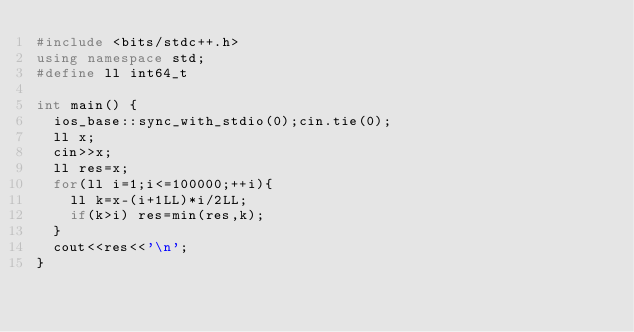Convert code to text. <code><loc_0><loc_0><loc_500><loc_500><_C++_>#include <bits/stdc++.h>
using namespace std;
#define ll int64_t

int main() {
	ios_base::sync_with_stdio(0);cin.tie(0);
	ll x;
	cin>>x;
	ll res=x;
	for(ll i=1;i<=100000;++i){
		ll k=x-(i+1LL)*i/2LL;
		if(k>i) res=min(res,k);
	}
	cout<<res<<'\n';
}

</code> 